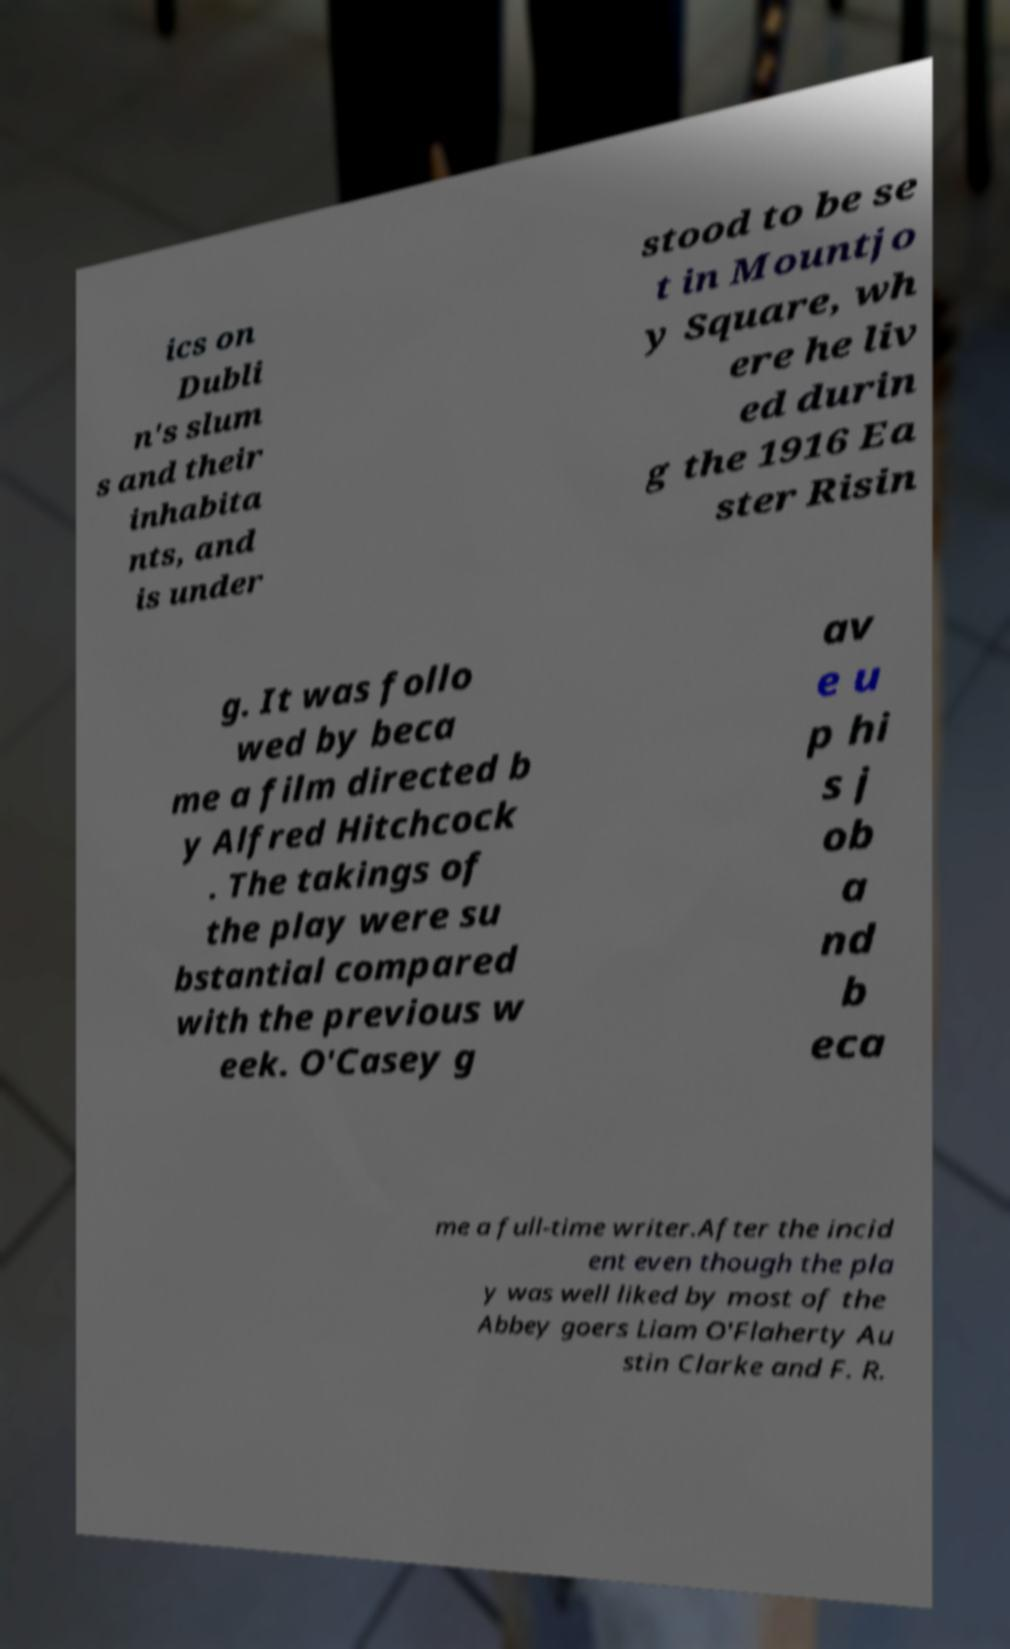What messages or text are displayed in this image? I need them in a readable, typed format. ics on Dubli n's slum s and their inhabita nts, and is under stood to be se t in Mountjo y Square, wh ere he liv ed durin g the 1916 Ea ster Risin g. It was follo wed by beca me a film directed b y Alfred Hitchcock . The takings of the play were su bstantial compared with the previous w eek. O'Casey g av e u p hi s j ob a nd b eca me a full-time writer.After the incid ent even though the pla y was well liked by most of the Abbey goers Liam O'Flaherty Au stin Clarke and F. R. 